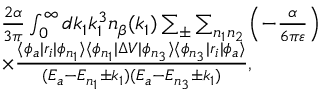<formula> <loc_0><loc_0><loc_500><loc_500>\begin{array} { r l } & { \frac { 2 \alpha } { 3 \pi } \int _ { 0 } ^ { \infty } d k _ { 1 } k _ { 1 } ^ { 3 } n _ { \beta } ( k _ { 1 } ) \sum _ { \pm } \sum _ { n _ { 1 } n _ { 2 } } \left ( - \frac { \alpha } { 6 \pi \varepsilon } \right ) } \\ & { \times \frac { \langle \phi _ { a } | r _ { i } | \phi _ { n _ { 1 } } \rangle \langle \phi _ { n _ { 1 } } | \Delta V | \phi _ { n _ { 3 } } \rangle \langle \phi _ { n _ { 3 } } | r _ { i } | \phi _ { a } \rangle } { ( E _ { a } - E _ { n _ { 1 } } \pm k _ { 1 } ) ( E _ { a } - E _ { n _ { 3 } } \pm k _ { 1 } ) } , } \end{array}</formula> 